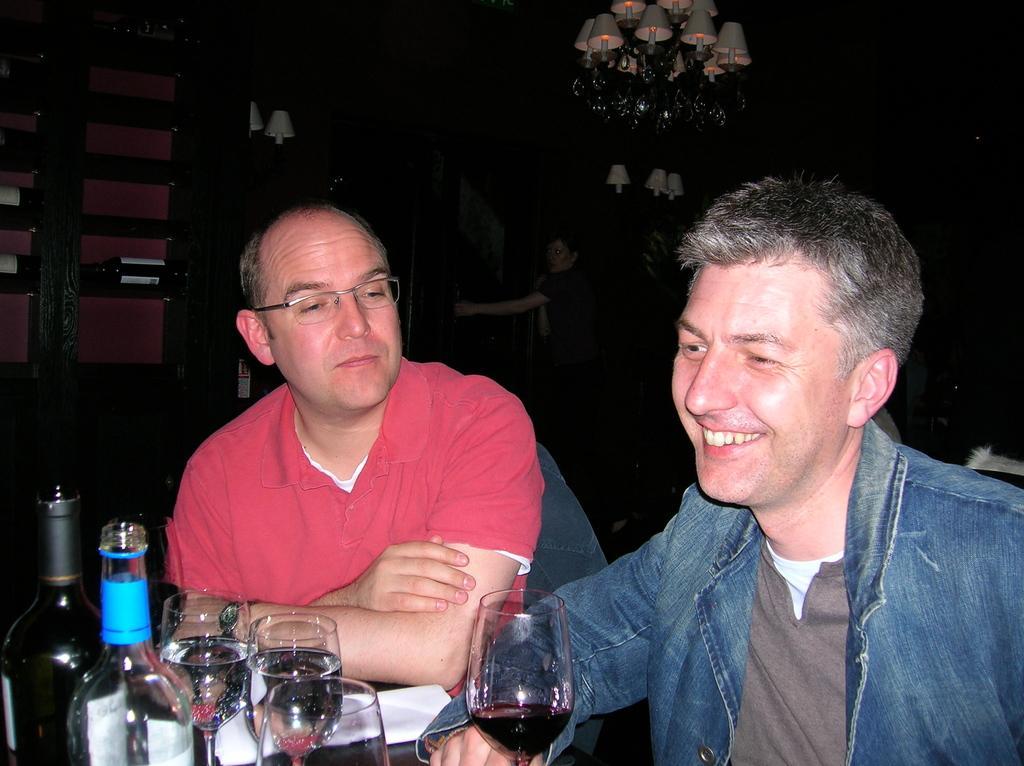In one or two sentences, can you explain what this image depicts? Man in red t-shirt is wearing spectacles. Beside him, man in blue jacket is smiling. In front of them, we see a table on which paper, glass and wine bottles are placed. 